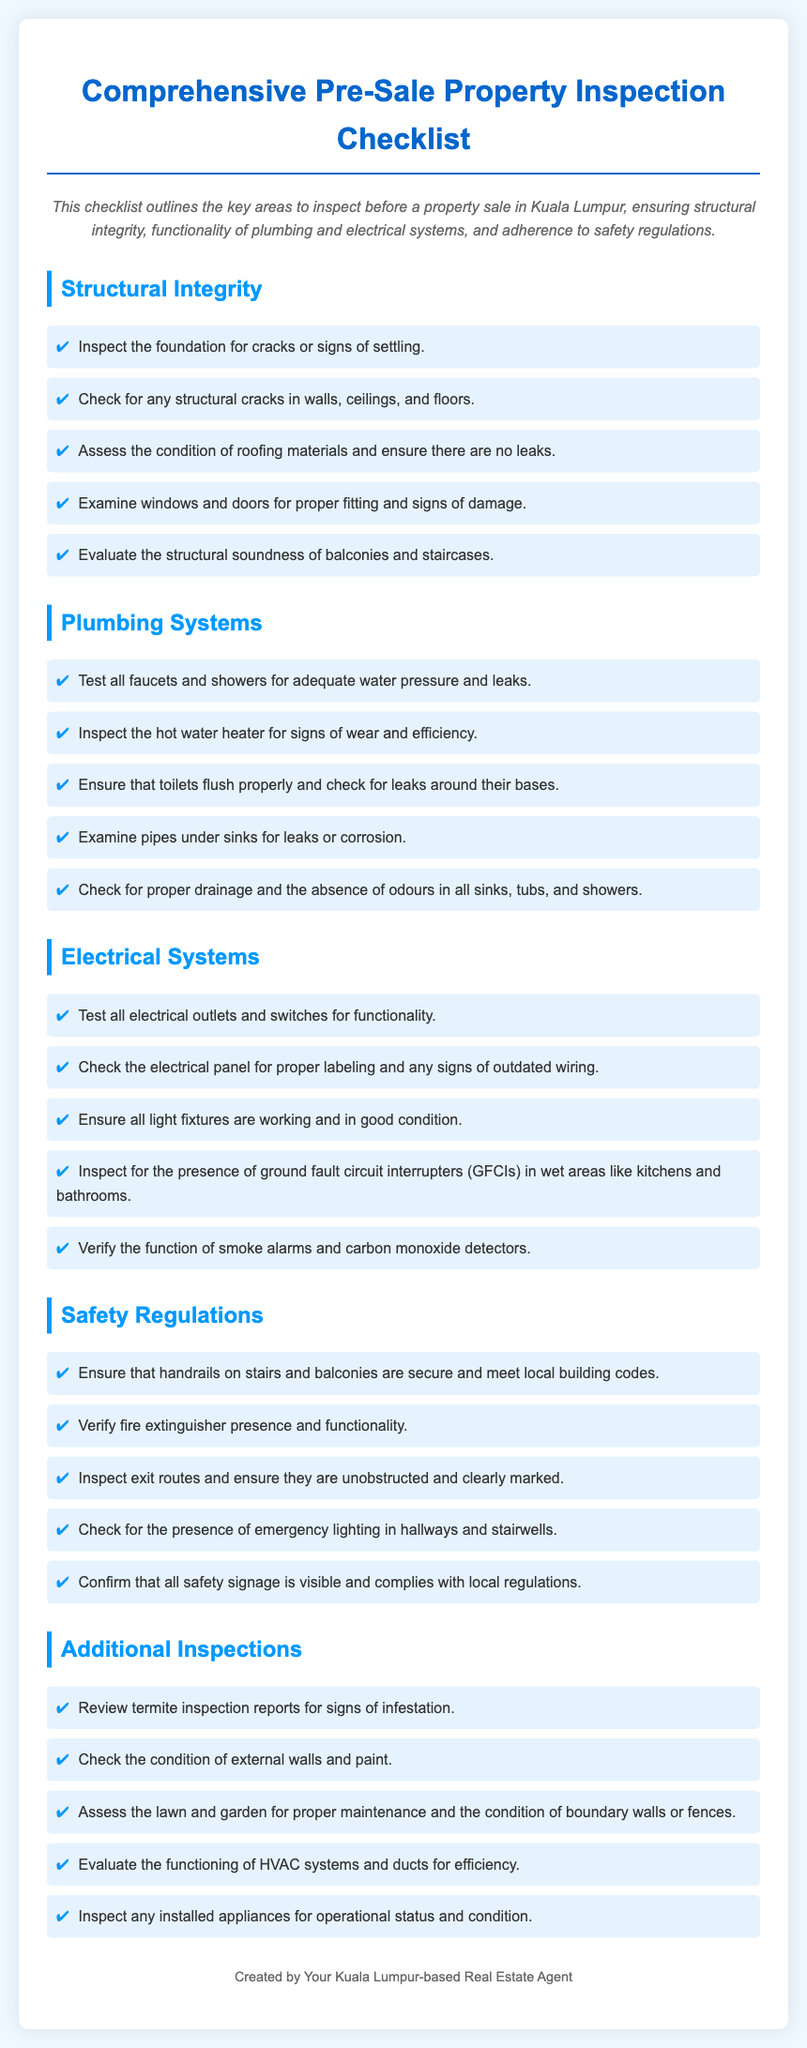what is the title of the document? The title of the document is presented at the top of the rendered checklist, which summarizes its purpose.
Answer: Comprehensive Pre-Sale Property Inspection Checklist how many main sections are in the checklist? The checklist is organized into several key sections that cover different areas to inspect, counted directly from the document.
Answer: Five what should be inspected in the plumbing systems section? The plumbing systems section includes specific items to check, listed as bullet points in the checklist.
Answer: Faucets, showers, water heater, toilets, pipes what indicates that the electrical panel is outdated? The document mentions specific signs to look for in the electrical panel, which must be noted for safety.
Answer: Signs of outdated wiring what is one requirement for safety regulations regarding handrails? Safety regulations include specific criteria that handrails must meet, directly referenced in the document.
Answer: Secure and meet local building codes what is checked under additional inspections? Additional inspections encompass extra areas to review beyond the main sections outlined, as mentioned in the checklist.
Answer: Termite inspection reports how many items are listed in the structural integrity section? The number of items can be counted from the list provided in the structural integrity section of the checklist.
Answer: Five why should smoke alarms be verified? The checklist emphasizes the importance of verifying smoke alarms for safety reasons related to fire hazards.
Answer: Safety reasons what should kitchen and bathroom areas have? There are specific safety features outlined that must be present in these areas, according to the checklist.
Answer: Ground fault circuit interrupters (GFCIs) 